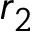<formula> <loc_0><loc_0><loc_500><loc_500>r _ { 2 }</formula> 